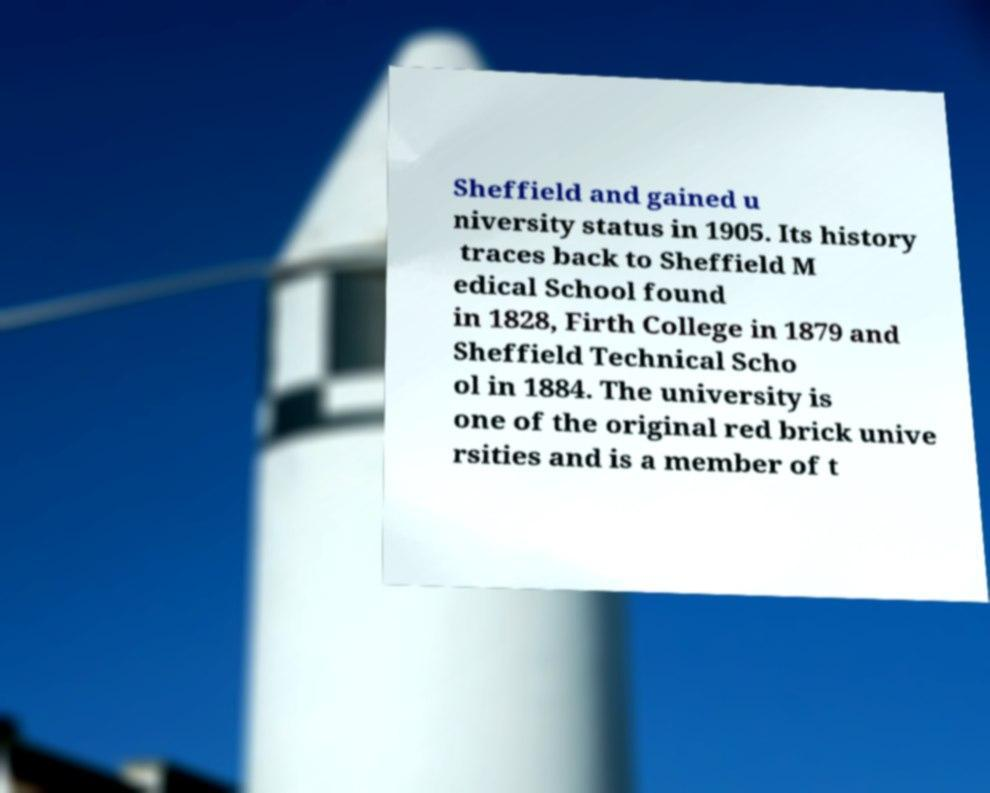For documentation purposes, I need the text within this image transcribed. Could you provide that? Sheffield and gained u niversity status in 1905. Its history traces back to Sheffield M edical School found in 1828, Firth College in 1879 and Sheffield Technical Scho ol in 1884. The university is one of the original red brick unive rsities and is a member of t 